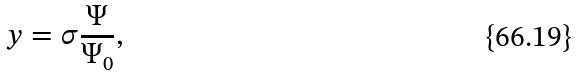<formula> <loc_0><loc_0><loc_500><loc_500>y = \sigma \frac { \Psi } { \Psi _ { 0 } } ,</formula> 